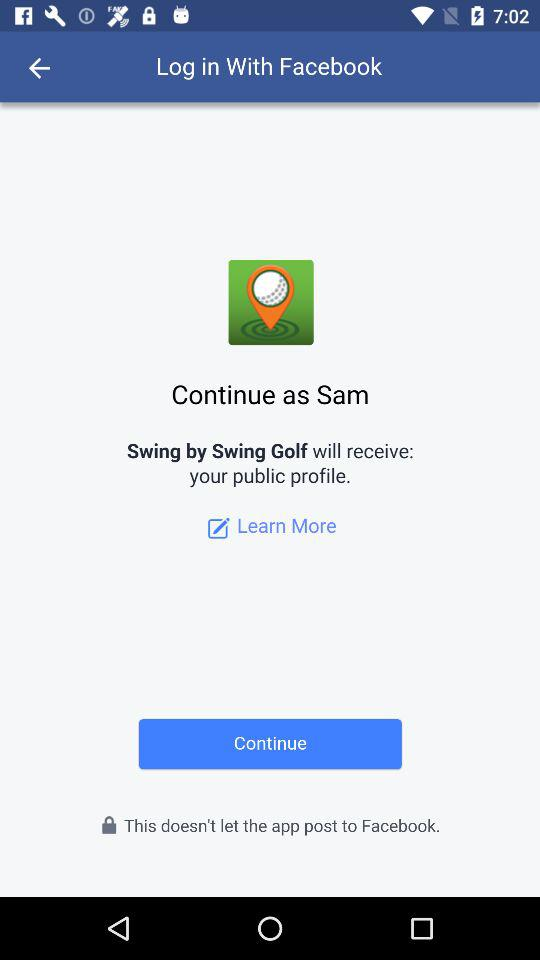What is the login name? The login name is Sam. 